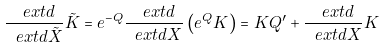Convert formula to latex. <formula><loc_0><loc_0><loc_500><loc_500>\frac { \ e x t d } { \ e x t d \tilde { X } } \tilde { K } = e ^ { - Q } \frac { \ e x t d } { \ e x t d X } \left ( e ^ { Q } K \right ) = K Q ^ { \prime } + \frac { \ e x t d } { \ e x t d X } K</formula> 